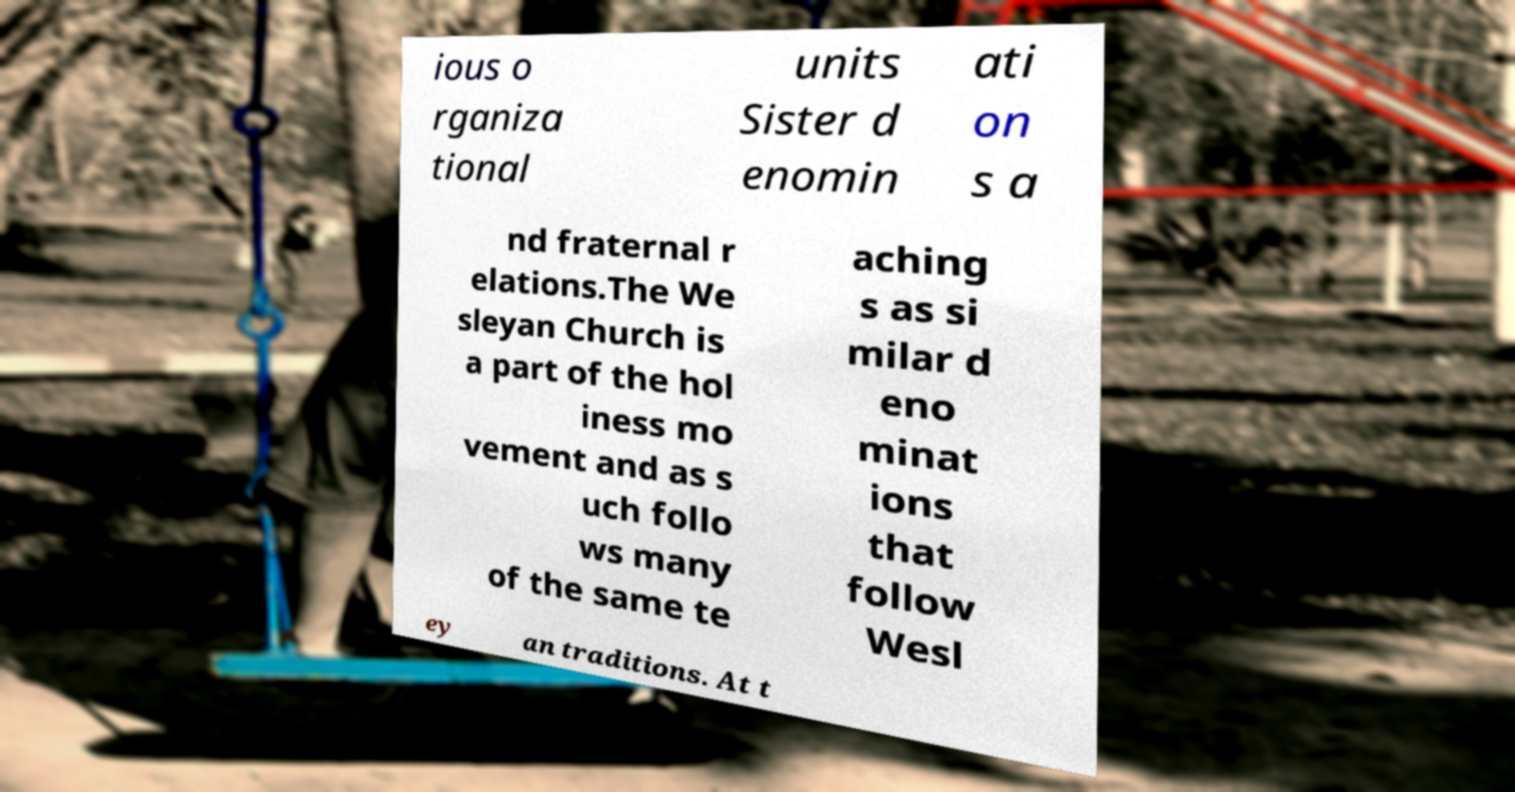Can you read and provide the text displayed in the image?This photo seems to have some interesting text. Can you extract and type it out for me? ious o rganiza tional units Sister d enomin ati on s a nd fraternal r elations.The We sleyan Church is a part of the hol iness mo vement and as s uch follo ws many of the same te aching s as si milar d eno minat ions that follow Wesl ey an traditions. At t 